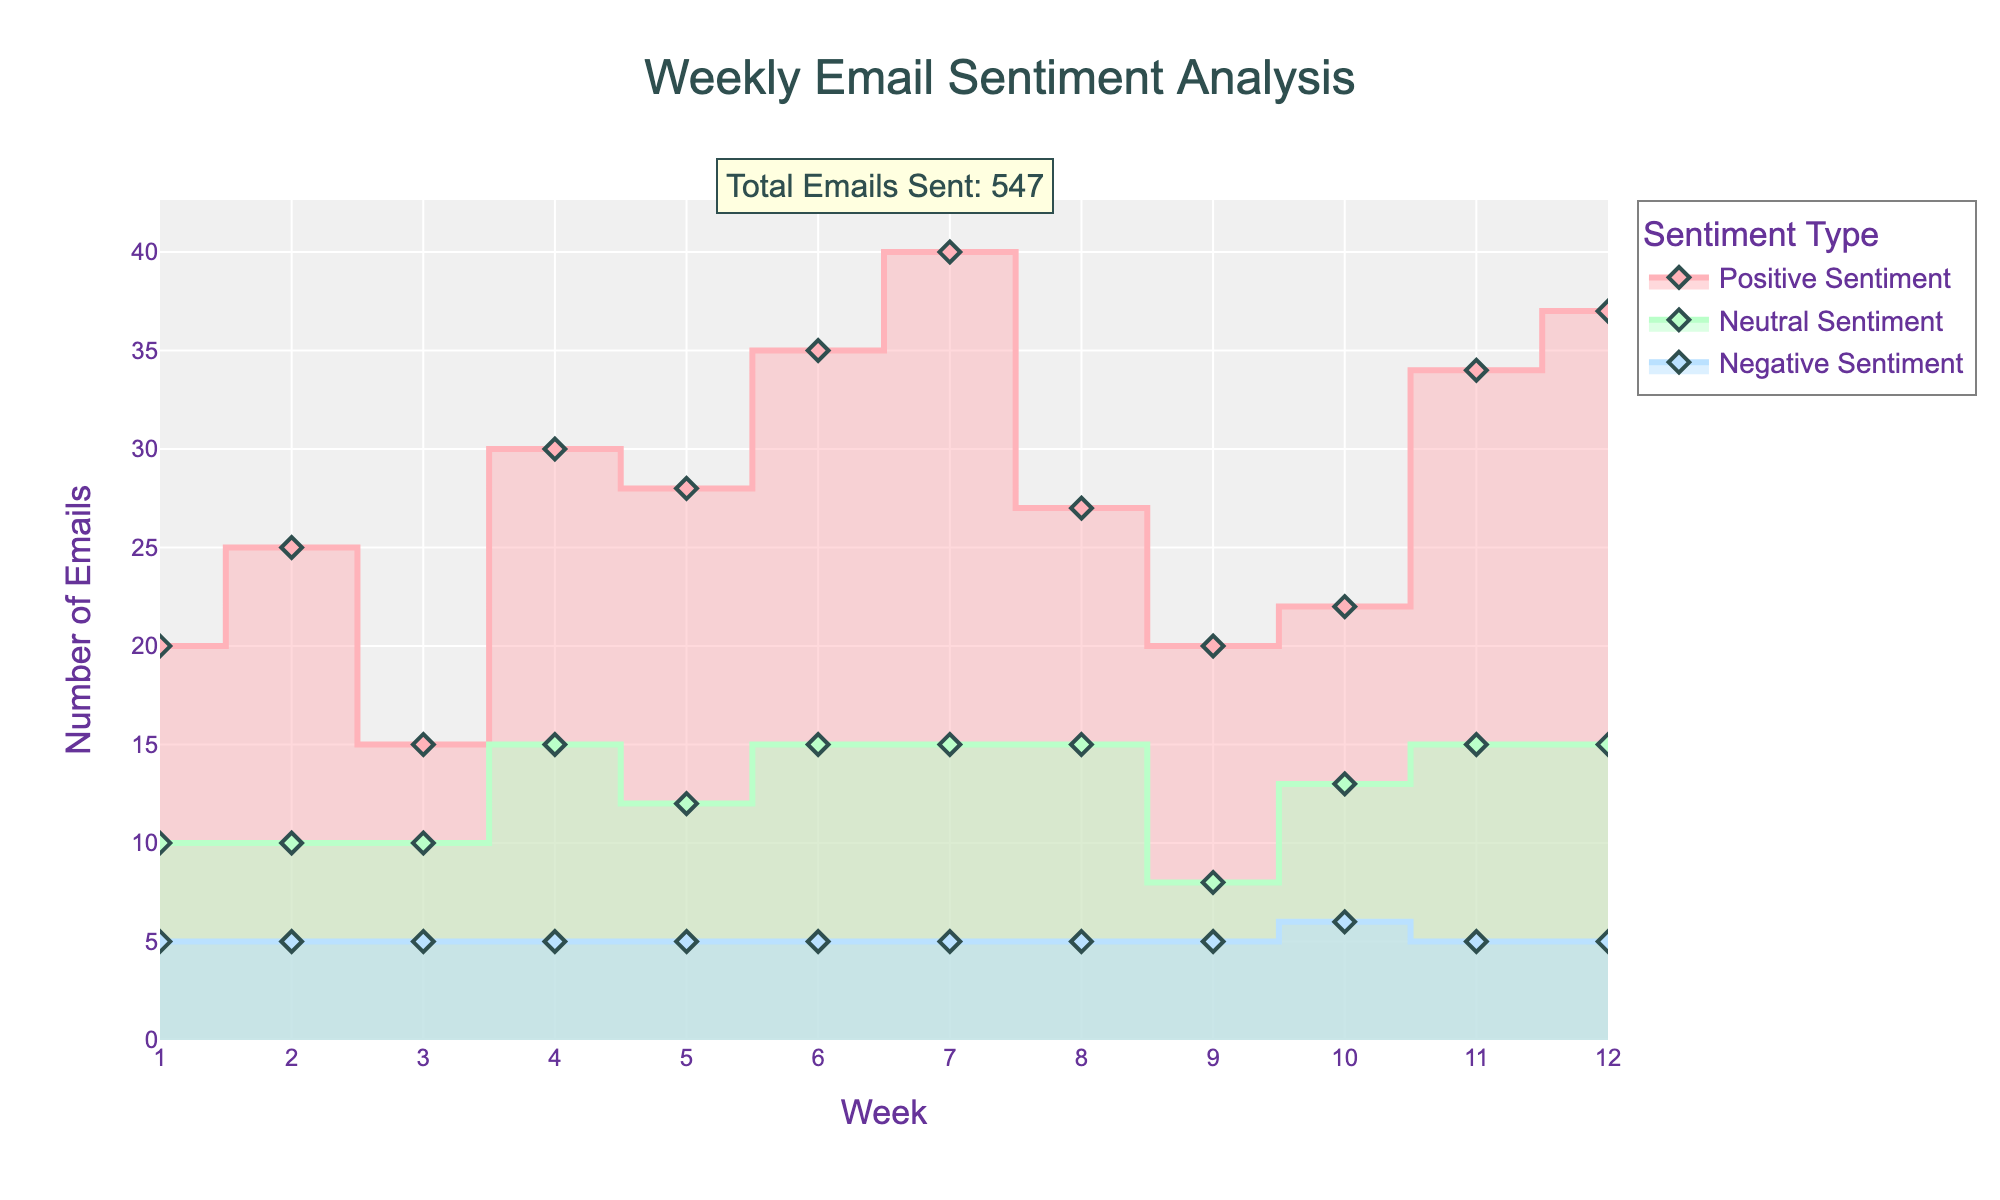What is the title of the plot? The title is located at the top of the plot and reads "Weekly Email Sentiment Analysis".
Answer: Weekly Email Sentiment Analysis How many weeks are represented in the plot? The x-axis of the plot shows the weeks labeled from 1 to 12, indicating 12 data points.
Answer: 12 Which sentiment type has the highest number of emails in Week 6? Week 6 shows three different sentiment lines, and the 'Positive Sentiment' line has the highest value at 35 emails.
Answer: Positive Sentiment What is the total number of emails sent across all weeks? The annotation at the top of the plot states the total number of emails sent as 617.
Answer: 617 Which week had the highest number of Negative Sentiment emails? Reviewing the plot, each week's negative sentiment reaches a peak of 5 emails, so all weeks have the same highest number for Negative Sentiment.
Answer: All weeks How does Week 4's Positive Sentiment compare to Week 7's Positive Sentiment? The line for Positive Sentiment in Week 4 is at 30 emails whereas in Week 7 it reaches 40 emails, meaning Week 7 has 10 more Positive Sentiment emails.
Answer: Week 7 is higher by 10 emails Which sentiment type has the most variation from week to week? The 'Positive Sentiment' line varies widely with increases and decreases, while 'Neutral' and 'Negative Sentiment' lines are more stable.
Answer: Positive Sentiment What is the average number of Neutral Sentiment emails per week? The Neutral Sentiment emails are summed over all weeks (10+10+10+15+12+15+15+15+8+13+15+15=153), and we divide 153 by 12 weeks to get a weekly average of approximately 12.75 emails.
Answer: 12.75 